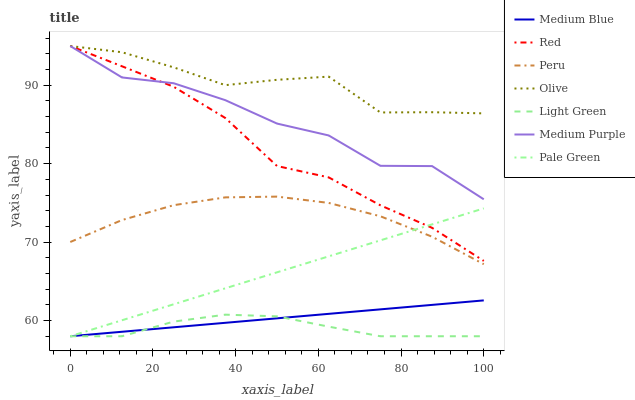Does Light Green have the minimum area under the curve?
Answer yes or no. Yes. Does Medium Blue have the minimum area under the curve?
Answer yes or no. No. Does Medium Blue have the maximum area under the curve?
Answer yes or no. No. Is Medium Blue the smoothest?
Answer yes or no. Yes. Is Medium Purple the roughest?
Answer yes or no. Yes. Is Medium Purple the smoothest?
Answer yes or no. No. Is Medium Blue the roughest?
Answer yes or no. No. Does Medium Purple have the lowest value?
Answer yes or no. No. Does Medium Blue have the highest value?
Answer yes or no. No. Is Peru less than Red?
Answer yes or no. Yes. Is Red greater than Peru?
Answer yes or no. Yes. Does Peru intersect Red?
Answer yes or no. No. 